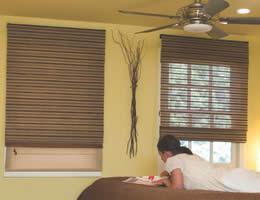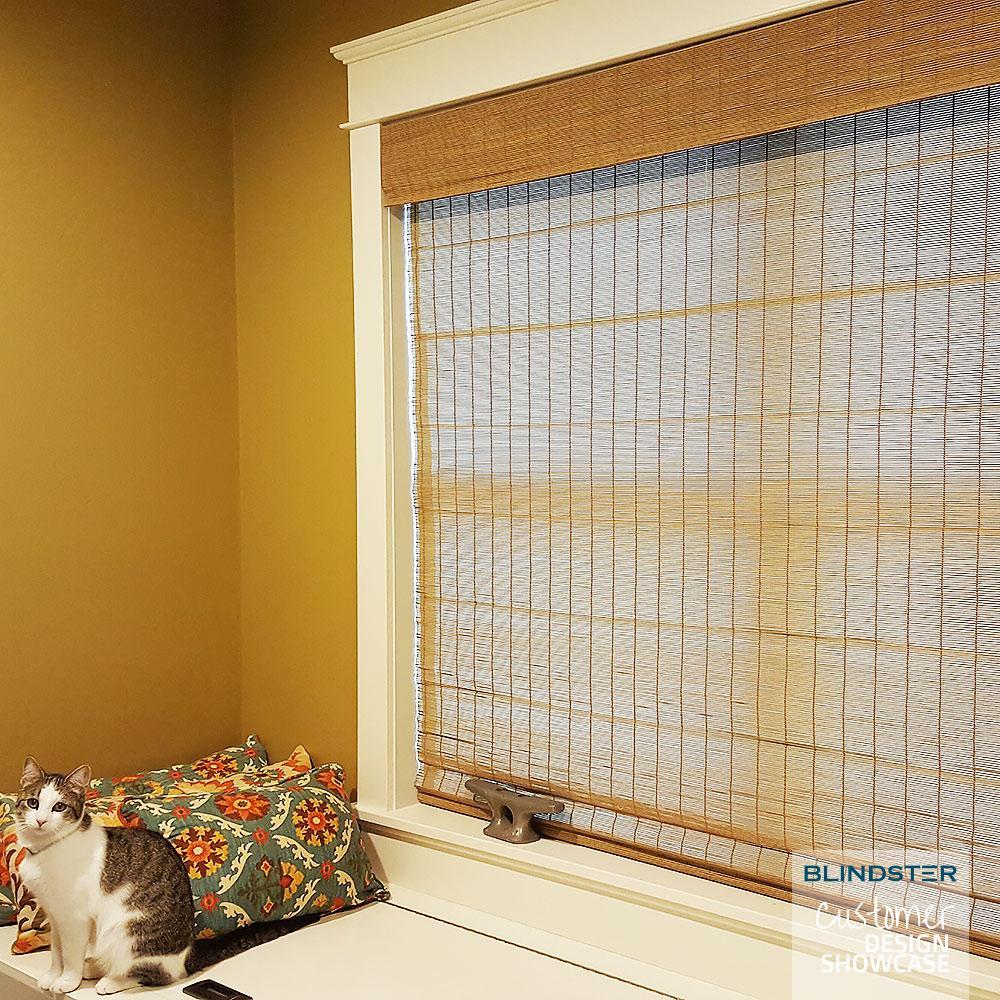The first image is the image on the left, the second image is the image on the right. Examine the images to the left and right. Is the description "There are exactly three shades in the left image." accurate? Answer yes or no. No. 